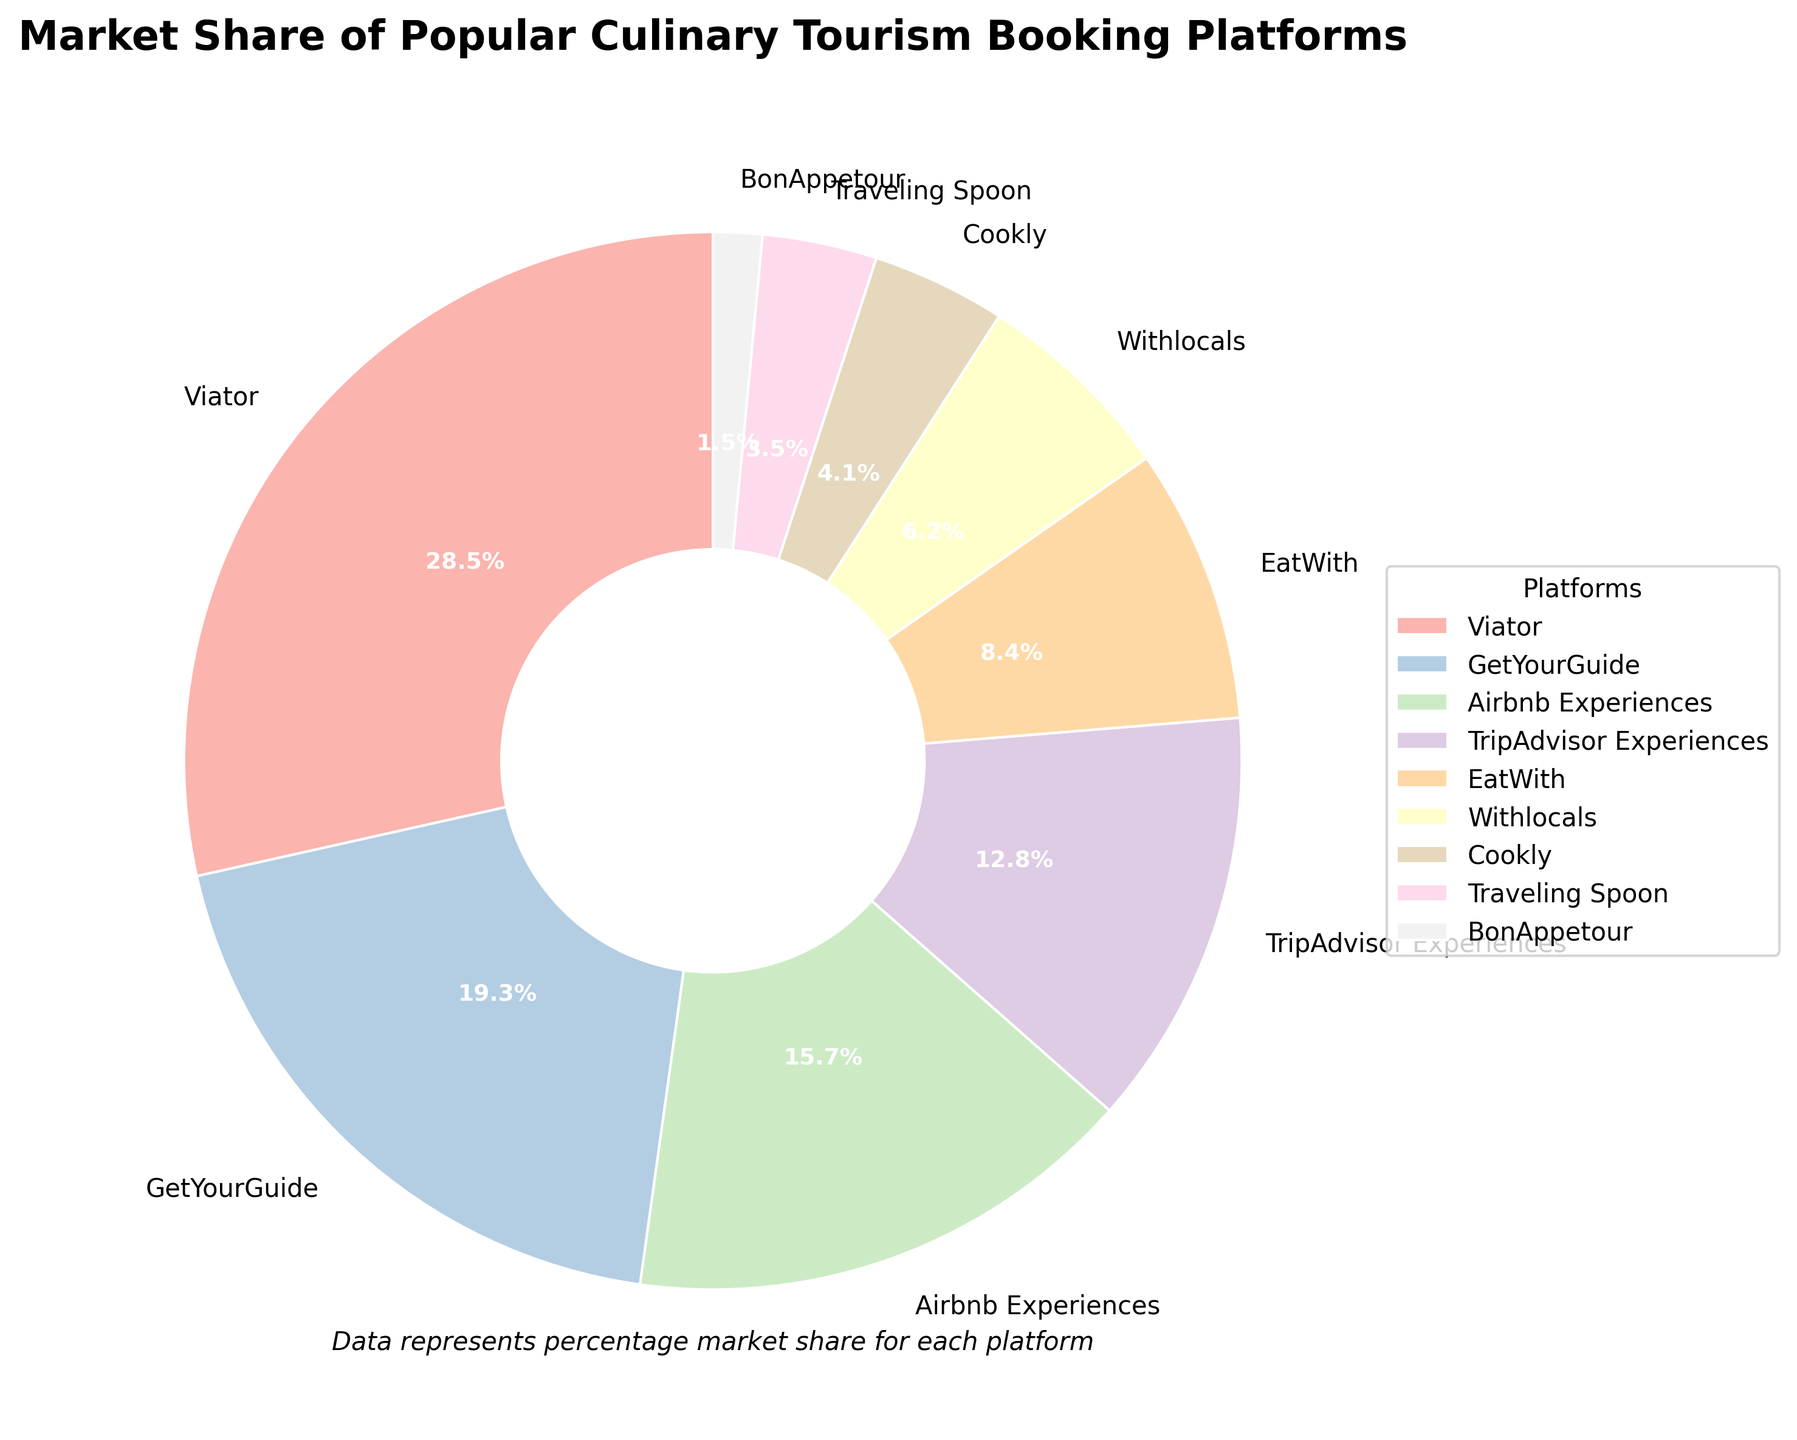Which platform holds the largest market share? By looking at the pie chart, the segment with the largest slice represents the platform with the highest market share. Viator has the largest segment.
Answer: Viator Which platform has the smallest market share? By examining the smallest slice in the pie chart, BonAppetour has the smallest market share.
Answer: BonAppetour What is the combined market share of GetYourGuide and Airbnb Experiences? To find the combined market share of GetYourGuide and Airbnb Experiences, add their percentages together: 19.3% + 15.7% = 35.0%.
Answer: 35.0% Which platforms have a market share greater than 10% but less than 20%? Identify the slices of the pie chart that fall within the range greater than 10% but less than 20%. GetYourGuide and Airbnb Experiences fit this criterion.
Answer: GetYourGuide and Airbnb Experiences What is the visual appearance (color) used for EatWith? Observe the color used for the EatWith segment in the pie chart. The slice representing EatWith is a specific shade in the Pastel color palette used.
Answer: Pastel color (exact shade not specified in the question) Among the platforms listed, which one occupies a larger share, Withlocals or Traveling Spoon? Compare the sizes of the segments representing Withlocals and Traveling Spoon. Withlocals has a larger segment than Traveling Spoon.
Answer: Withlocals Calculate the difference in market share between Viator and TripAdvisor Experiences. Subtract the market share percentage of TripAdvisor Experiences from that of Viator: 28.5% - 12.8% = 15.7%.
Answer: 15.7% What is the total market share of all platforms combined? Sum up the market shares of all platforms from the pie chart: 28.5 + 19.3 + 15.7 + 12.8 + 8.4 + 6.2 + 4.1 + 3.5 + 1.5 = 100.0%.
Answer: 100.0% Which platform has a market share that is almost half of Viator's? To find a platform with a market share almost half of Viator's (28.5%), look for a platform around 14.25% (half of 28.5%). Airbnb Experiences is closest to this with 15.7%.
Answer: Airbnb Experiences List platforms with a market share less than 5%. Identify slices representing platforms with a market share below 5%. Cookly, Traveling Spoon, and BonAppetour match this criterion.
Answer: Cookly, Traveling Spoon, and BonAppetour 